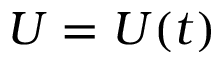Convert formula to latex. <formula><loc_0><loc_0><loc_500><loc_500>U = U ( t )</formula> 